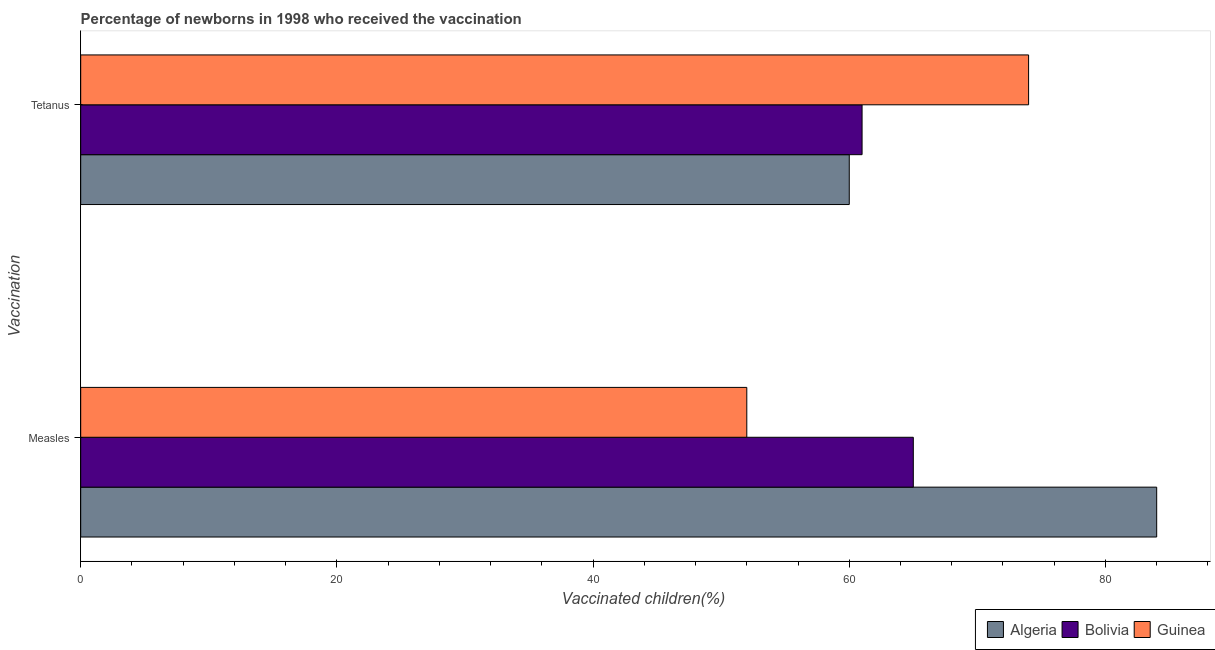Are the number of bars per tick equal to the number of legend labels?
Make the answer very short. Yes. Are the number of bars on each tick of the Y-axis equal?
Give a very brief answer. Yes. What is the label of the 1st group of bars from the top?
Your answer should be compact. Tetanus. What is the percentage of newborns who received vaccination for tetanus in Bolivia?
Your response must be concise. 61. Across all countries, what is the maximum percentage of newborns who received vaccination for tetanus?
Give a very brief answer. 74. Across all countries, what is the minimum percentage of newborns who received vaccination for tetanus?
Keep it short and to the point. 60. In which country was the percentage of newborns who received vaccination for tetanus maximum?
Your answer should be very brief. Guinea. In which country was the percentage of newborns who received vaccination for measles minimum?
Your answer should be very brief. Guinea. What is the total percentage of newborns who received vaccination for tetanus in the graph?
Ensure brevity in your answer.  195. What is the difference between the percentage of newborns who received vaccination for measles in Bolivia and that in Algeria?
Offer a very short reply. -19. What is the difference between the percentage of newborns who received vaccination for tetanus in Guinea and the percentage of newborns who received vaccination for measles in Bolivia?
Keep it short and to the point. 9. What is the average percentage of newborns who received vaccination for tetanus per country?
Keep it short and to the point. 65. What is the difference between the percentage of newborns who received vaccination for tetanus and percentage of newborns who received vaccination for measles in Algeria?
Your answer should be compact. -24. In how many countries, is the percentage of newborns who received vaccination for tetanus greater than 40 %?
Offer a very short reply. 3. What is the ratio of the percentage of newborns who received vaccination for tetanus in Algeria to that in Guinea?
Provide a short and direct response. 0.81. Is the percentage of newborns who received vaccination for tetanus in Guinea less than that in Algeria?
Ensure brevity in your answer.  No. What does the 3rd bar from the top in Measles represents?
Your response must be concise. Algeria. What does the 3rd bar from the bottom in Tetanus represents?
Make the answer very short. Guinea. How many bars are there?
Provide a succinct answer. 6. Are all the bars in the graph horizontal?
Your response must be concise. Yes. Does the graph contain any zero values?
Ensure brevity in your answer.  No. Where does the legend appear in the graph?
Your answer should be very brief. Bottom right. What is the title of the graph?
Your response must be concise. Percentage of newborns in 1998 who received the vaccination. What is the label or title of the X-axis?
Your answer should be very brief. Vaccinated children(%)
. What is the label or title of the Y-axis?
Your response must be concise. Vaccination. What is the Vaccinated children(%)
 in Algeria in Measles?
Ensure brevity in your answer.  84. What is the Vaccinated children(%)
 in Guinea in Measles?
Make the answer very short. 52. What is the Vaccinated children(%)
 of Algeria in Tetanus?
Give a very brief answer. 60. What is the Vaccinated children(%)
 of Guinea in Tetanus?
Ensure brevity in your answer.  74. Across all Vaccination, what is the maximum Vaccinated children(%)
 in Bolivia?
Give a very brief answer. 65. Across all Vaccination, what is the maximum Vaccinated children(%)
 of Guinea?
Offer a very short reply. 74. Across all Vaccination, what is the minimum Vaccinated children(%)
 in Guinea?
Provide a succinct answer. 52. What is the total Vaccinated children(%)
 of Algeria in the graph?
Ensure brevity in your answer.  144. What is the total Vaccinated children(%)
 of Bolivia in the graph?
Your answer should be very brief. 126. What is the total Vaccinated children(%)
 in Guinea in the graph?
Your response must be concise. 126. What is the difference between the Vaccinated children(%)
 in Bolivia in Measles and that in Tetanus?
Offer a terse response. 4. What is the difference between the Vaccinated children(%)
 in Algeria in Measles and the Vaccinated children(%)
 in Guinea in Tetanus?
Keep it short and to the point. 10. What is the average Vaccinated children(%)
 in Bolivia per Vaccination?
Offer a terse response. 63. What is the difference between the Vaccinated children(%)
 of Algeria and Vaccinated children(%)
 of Guinea in Measles?
Your answer should be compact. 32. What is the difference between the Vaccinated children(%)
 in Bolivia and Vaccinated children(%)
 in Guinea in Measles?
Your response must be concise. 13. What is the difference between the Vaccinated children(%)
 of Algeria and Vaccinated children(%)
 of Bolivia in Tetanus?
Make the answer very short. -1. What is the difference between the Vaccinated children(%)
 of Algeria and Vaccinated children(%)
 of Guinea in Tetanus?
Your answer should be compact. -14. What is the difference between the Vaccinated children(%)
 in Bolivia and Vaccinated children(%)
 in Guinea in Tetanus?
Ensure brevity in your answer.  -13. What is the ratio of the Vaccinated children(%)
 of Algeria in Measles to that in Tetanus?
Give a very brief answer. 1.4. What is the ratio of the Vaccinated children(%)
 of Bolivia in Measles to that in Tetanus?
Offer a very short reply. 1.07. What is the ratio of the Vaccinated children(%)
 in Guinea in Measles to that in Tetanus?
Your response must be concise. 0.7. What is the difference between the highest and the second highest Vaccinated children(%)
 in Algeria?
Provide a succinct answer. 24. What is the difference between the highest and the second highest Vaccinated children(%)
 of Bolivia?
Ensure brevity in your answer.  4. What is the difference between the highest and the lowest Vaccinated children(%)
 of Algeria?
Provide a succinct answer. 24. 